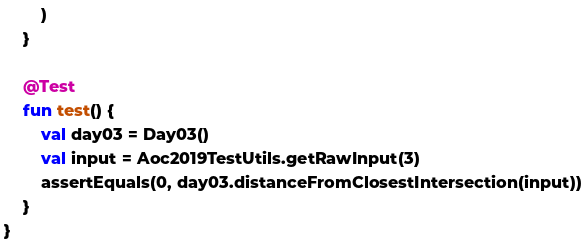<code> <loc_0><loc_0><loc_500><loc_500><_Kotlin_>        )
    }

    @Test
    fun test() {
        val day03 = Day03()
        val input = Aoc2019TestUtils.getRawInput(3)
        assertEquals(0, day03.distanceFromClosestIntersection(input))
    }
}
</code> 